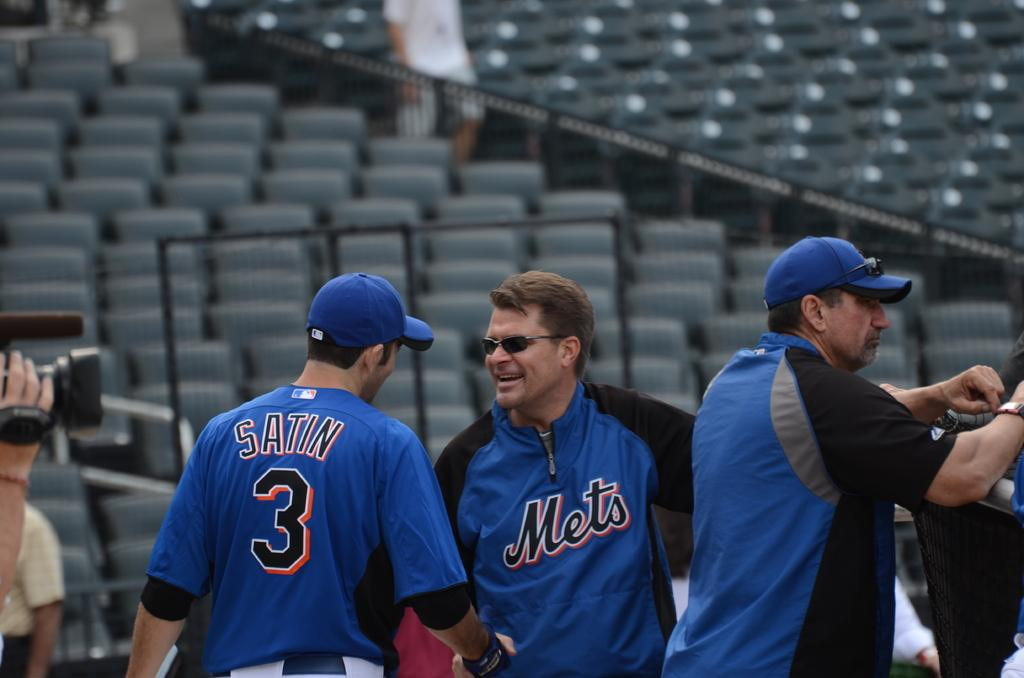<image>
Create a compact narrative representing the image presented. Men with Mets jerseys on speak to each other on a field. 